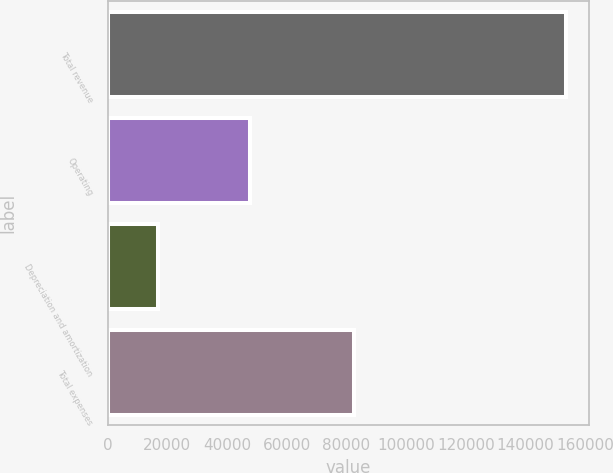Convert chart. <chart><loc_0><loc_0><loc_500><loc_500><bar_chart><fcel>Total revenue<fcel>Operating<fcel>Depreciation and amortization<fcel>Total expenses<nl><fcel>153625<fcel>47593<fcel>17013<fcel>82512<nl></chart> 